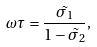<formula> <loc_0><loc_0><loc_500><loc_500>\omega \tau = \frac { \tilde { \sigma _ { 1 } } } { 1 - \tilde { \sigma _ { 2 } } } ,</formula> 